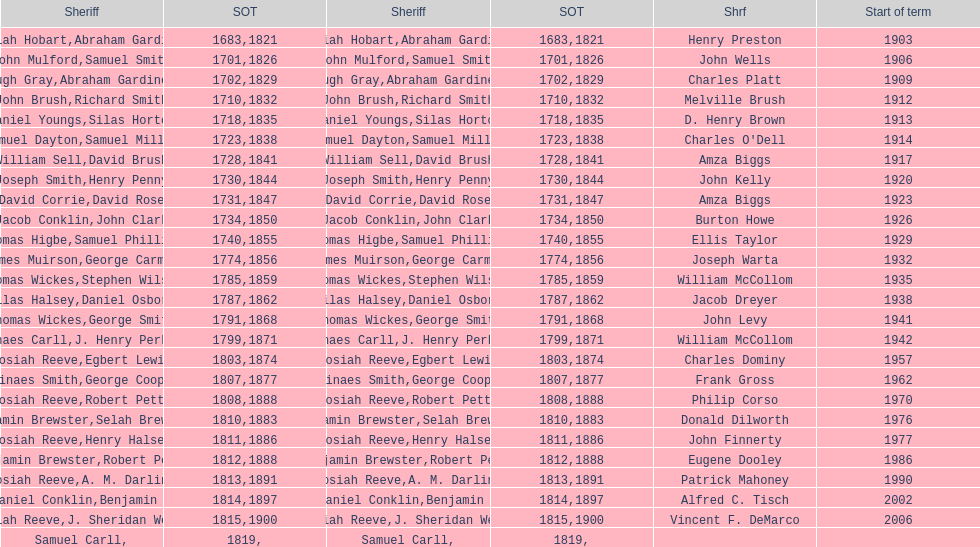Did robert petty serve before josiah reeve? No. 